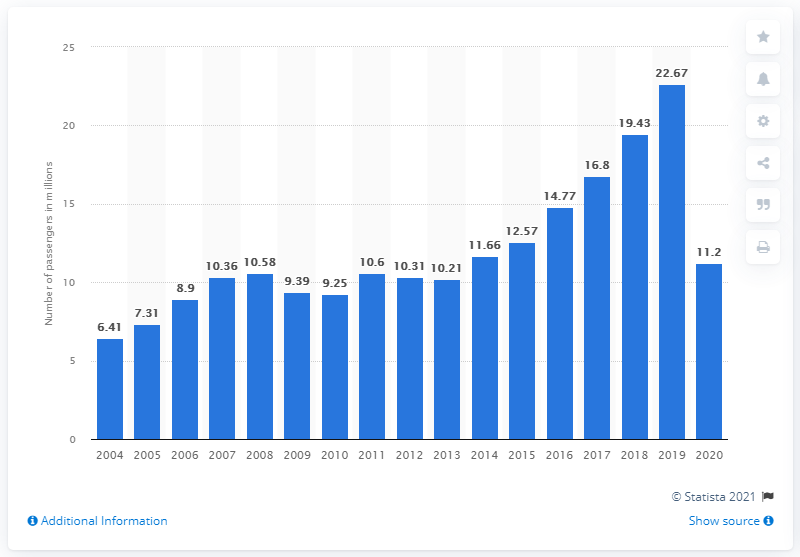Highlight a few significant elements in this photo. Frontier Airlines carried 11,200 passengers in 2020. 